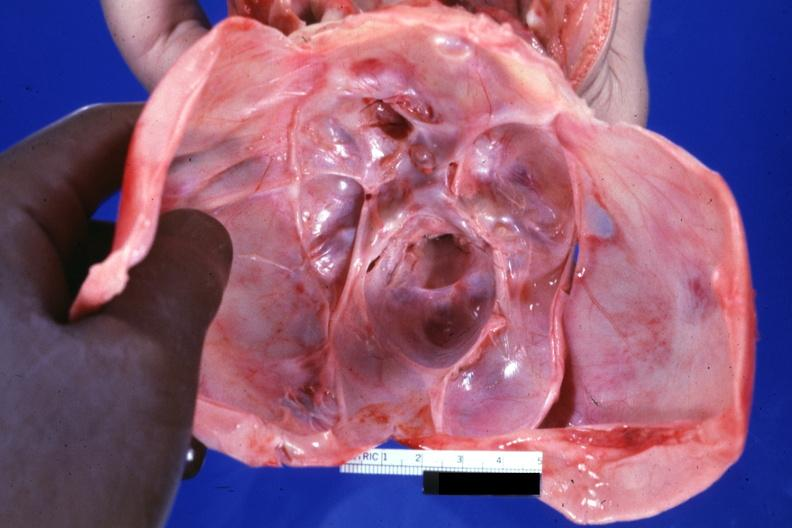what is present?
Answer the question using a single word or phrase. Malformed base 